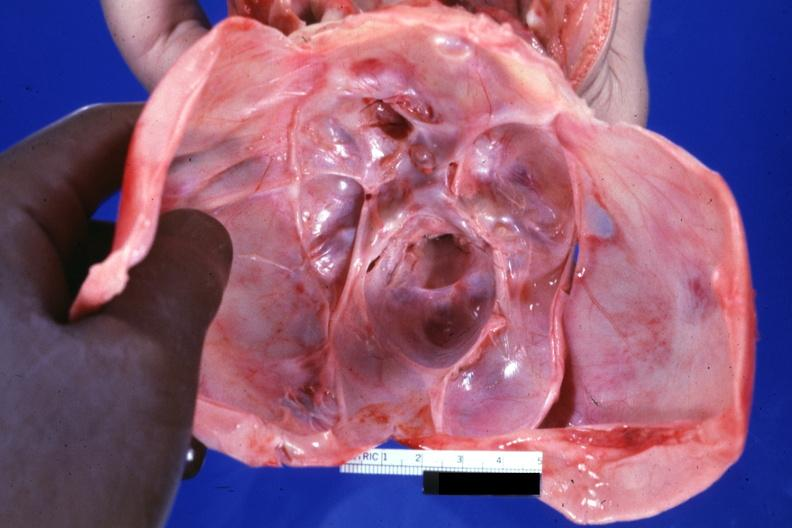what is present?
Answer the question using a single word or phrase. Malformed base 